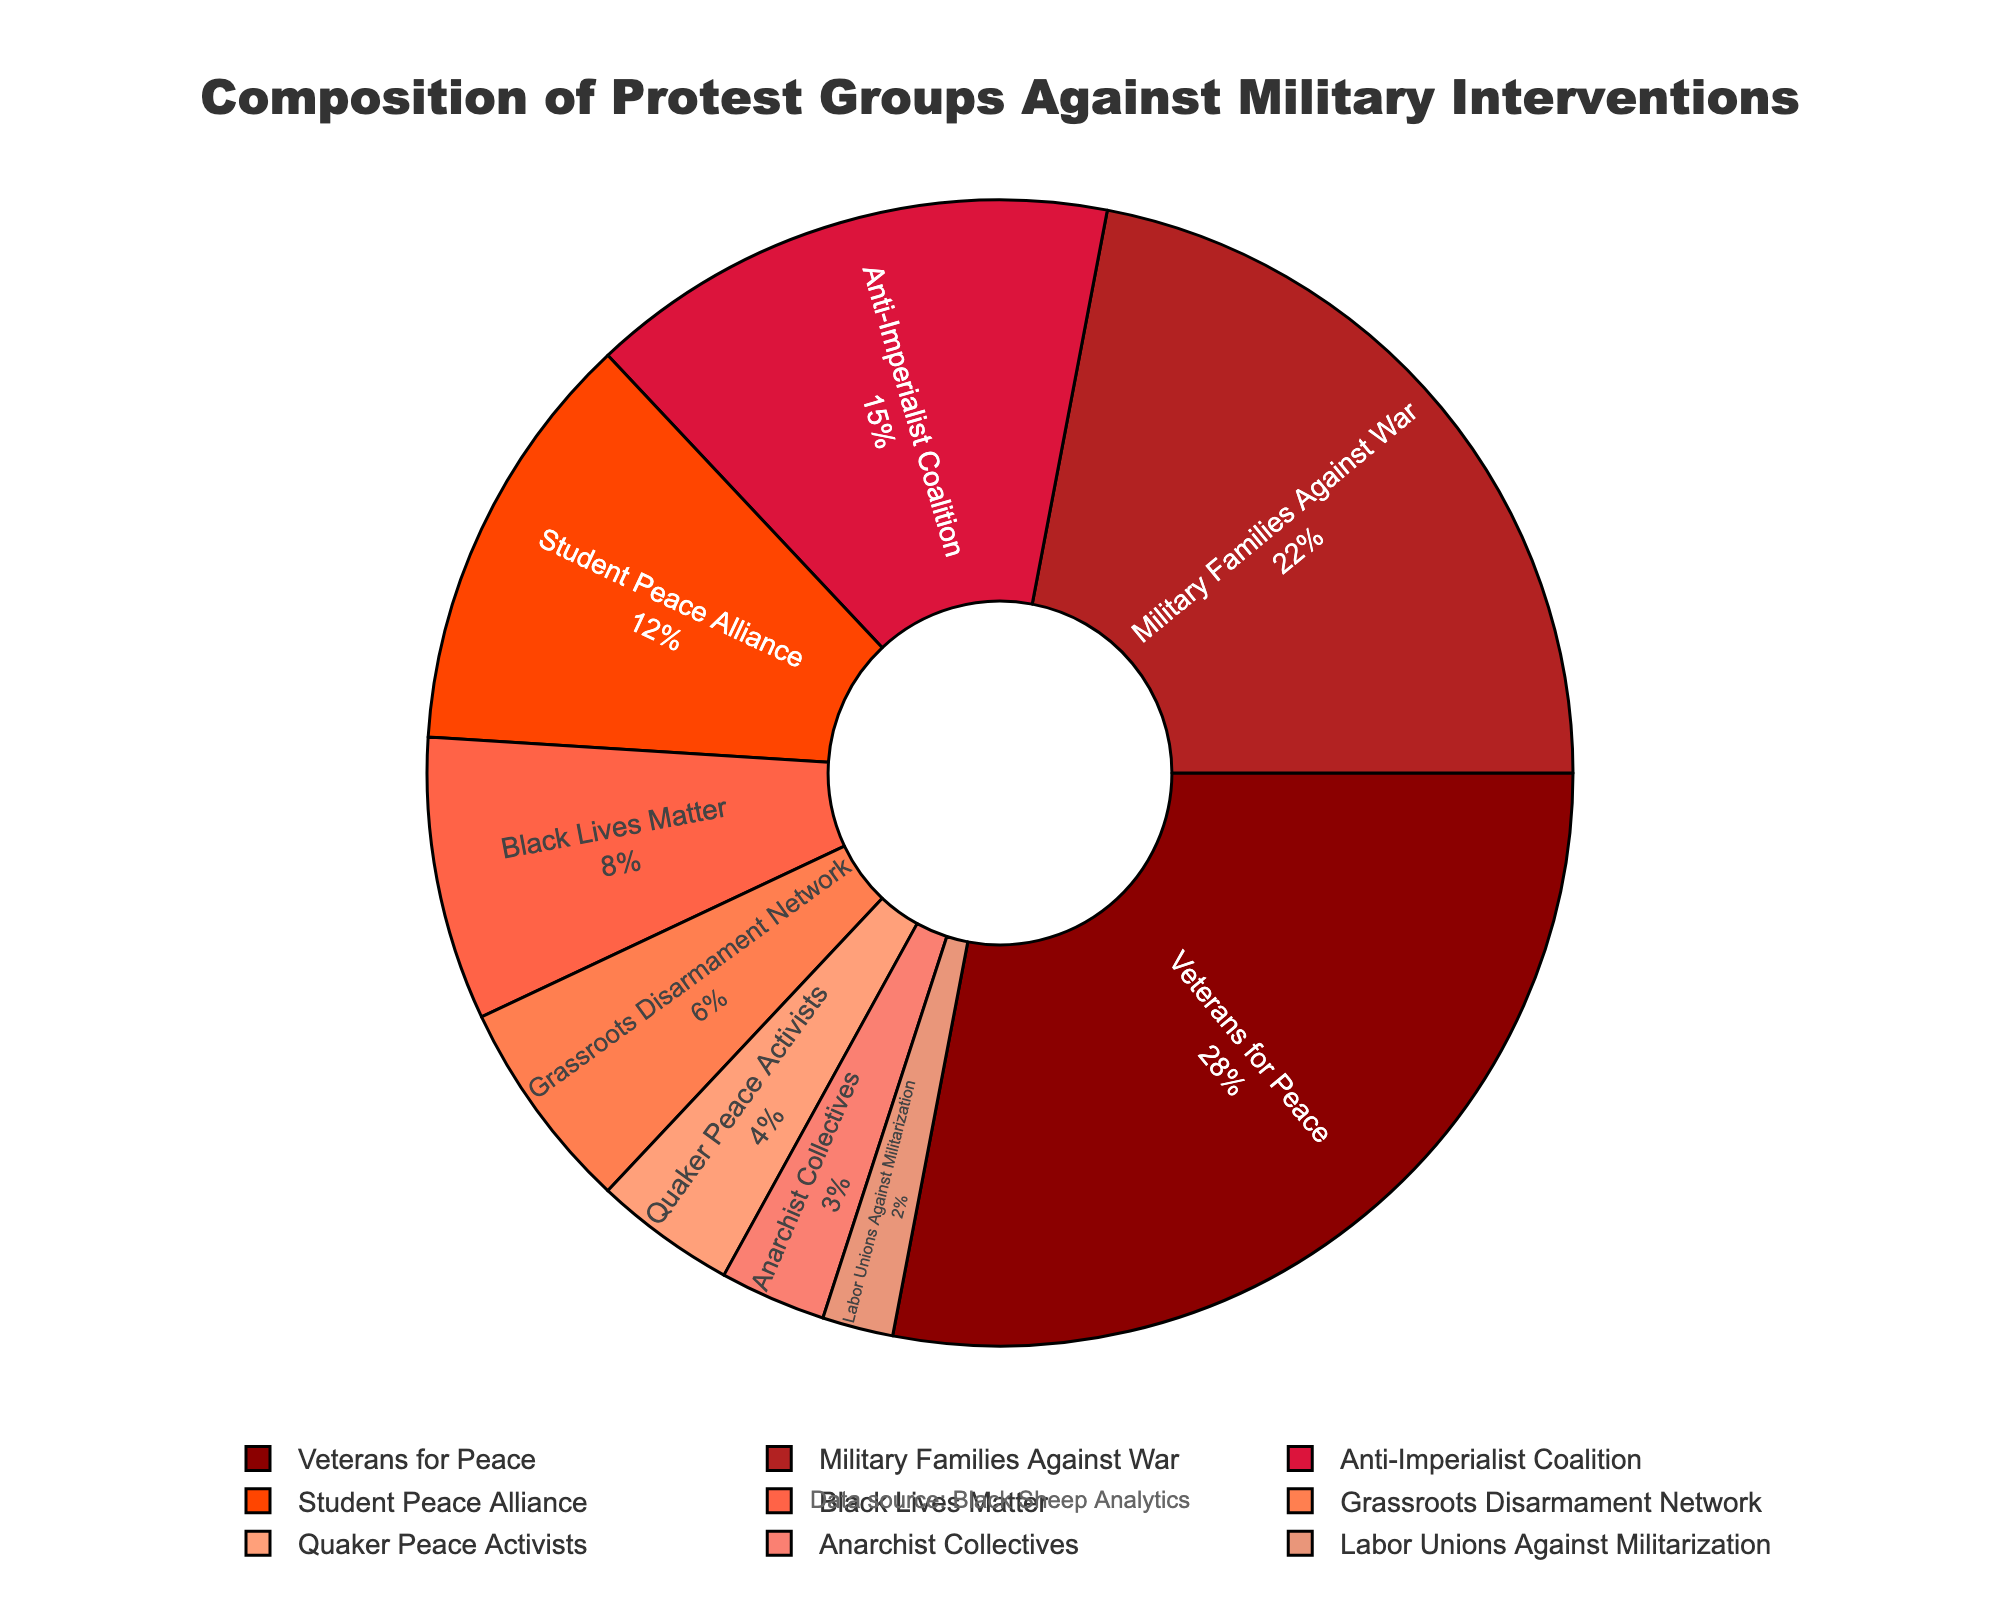What is the combined percentage of Veterans for Peace and Military Families Against War? To find the combined percentage, sum the percentages of Veterans for Peace (28%) and Military Families Against War (22%). So, 28 + 22 = 50.
Answer: 50% Which group has the smallest representation in the protest groups? The group with the smallest percentage is Labor Unions Against Militarization, which has 2% representation.
Answer: Labor Unions Against Militarization How much larger is the percentage of Veterans for Peace compared to Black Lives Matter? Subtract the percentage of Black Lives Matter (8%) from Veterans for Peace (28%). So, 28 - 8 = 20.
Answer: 20% What is the average percentage of the Anti-Imperialist Coalition, Quaker Peace Activists, and Anarchist Collectives? Sum the percentages of these three groups: 15 + 4 + 3 = 22, then divide by 3 (the number of groups). So, 22/3 ≈ 7.33.
Answer: 7.33% Which groups have percentages within the range of 5% to 15% inclusive? The groups within this range are Anti-Imperialist Coalition (15%), Student Peace Alliance (12%), and Grassroots Disarmament Network (6%).
Answer: Anti-Imperialist Coalition, Student Peace Alliance, Grassroots Disarmament Network Which color represents the Student Peace Alliance on the pie chart? The Student Peace Alliance is labeled with the fourth segment from the start, colored light orange.
Answer: Light orange Which groups combined make up less than 10% of the protest groups? The groups with less than 10% representation are Black Lives Matter (8%), Grassroots Disarmament Network (6%), Quaker Peace Activists (4%), Anarchist Collectives (3%), and Labor Unions Against Militarization (2%).
Answer: Black Lives Matter, Grassroots Disarmament Network, Quaker Peace Activists, Anarchist Collectives, Labor Unions Against Militarization What is the difference in percentage between the largest and smallest groups represented? Subtract the smallest percentage (2%, Labor Unions Against Militarization) from the largest percentage (28%, Veterans for Peace). So, 28 - 2 = 26.
Answer: 26% If Veterans for Peace and Military Families Against War formed one group, what percentage of the whole would this new group be? Sum the percentages of Veterans for Peace and Military Families Against War: 28 + 22 = 50.
Answer: 50% 